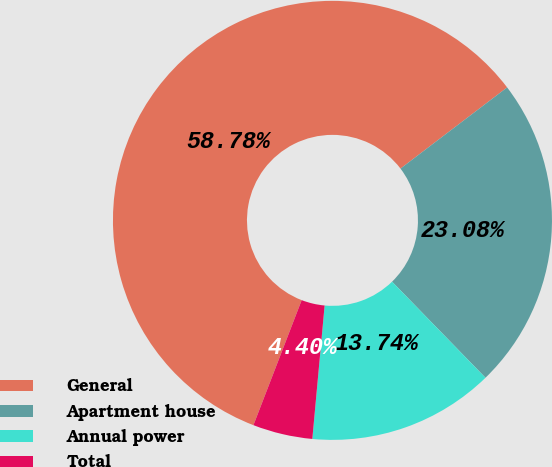<chart> <loc_0><loc_0><loc_500><loc_500><pie_chart><fcel>General<fcel>Apartment house<fcel>Annual power<fcel>Total<nl><fcel>58.79%<fcel>23.08%<fcel>13.74%<fcel>4.4%<nl></chart> 